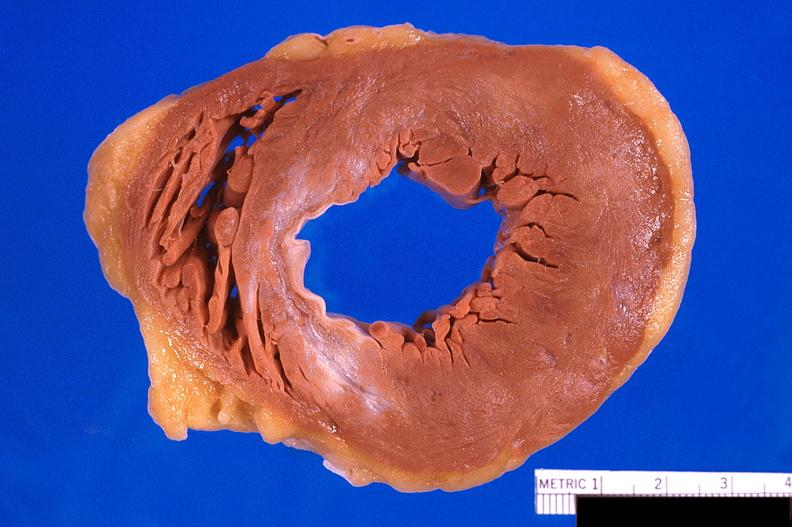s cardiovascular present?
Answer the question using a single word or phrase. Yes 